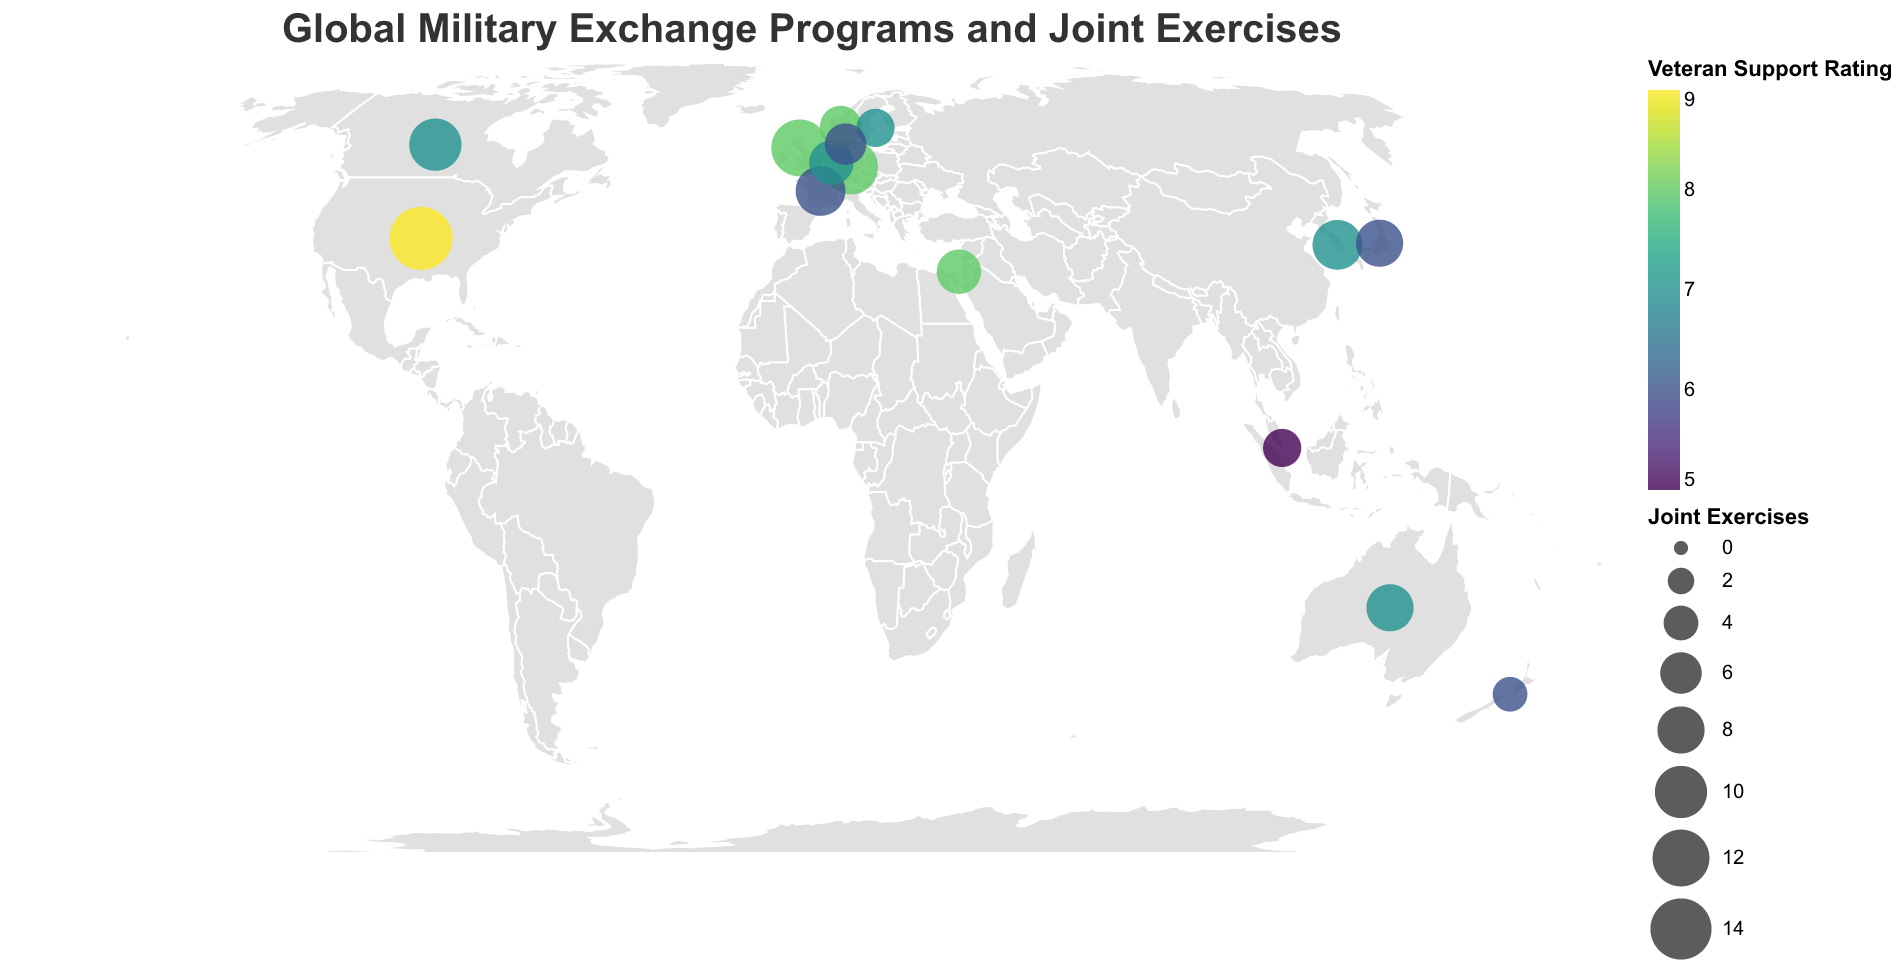What's the title of the figure? The title is usually located at the top of the figure and is clearly stated. Here, it reads "Global Military Exchange Programs and Joint Exercises".
Answer: Global Military Exchange Programs and Joint Exercises How is the size of each circle on the plot determined? The size of each circle is based on the number of Joint Exercises that a country participates in. This can be inferred from the "size" legend referring to Joint Exercises.
Answer: Number of Joint Exercises Which country has the highest Veteran Support Rating and how is it visually represented? By examining the color indicator on the plot, we see that darker colors correspond to a higher Veteran Support Rating. The United States, which is a dark shade close to the value 9 in the legend, has the highest Veteran Support Rating.
Answer: United States How many countries participate in 6 Joint Exercises? By looking at the plot and identifying the circles whose size corresponds to 6 Joint Exercises: Australia, Denmark, Norway, and the Netherlands all have 6 Joint Exercises.
Answer: 4 countries Which country offers the most exchange programs? Examining the tooltip for each country shows that the United States offers the most exchange programs with a value of 10.
Answer: United States Compare the Veteran Support Rating of the United Kingdom and Germany. Which one is higher? Both countries have different shades on the plot. According to the tooltip, the United Kingdom has a Veteran Support Rating of 8, while Germany also has a rating of 8. Thus, they are equal.
Answer: Equal What is the average number of Joint Exercises among countries with a Veteran Support Rating of 7? Countries with a Veteran Support Rating of 7 are Canada, Australia, South Korea, Netherlands, and Sweden. Their Joint Exercise numbers are 10, 8, 9, 7, and 5 respectively. The average is (10 + 8 + 9 + 7 + 5) / 5 = 39 / 5 = 7.8
Answer: 7.8 Which countries have a Veteran Support Rating less than 7? The plot shows different shades indicating the Veteran Support Rating. The tooltip helps identify that France (6), Japan (6), Denmark (6), New Zealand (6), and Singapore (5) have a Veteran Support Rating below 7.
Answer: France, Japan, Denmark, New Zealand, Singapore Identify the country in the Southern Hemisphere with the highest number of Joint Exercises. In the Southern Hemisphere, countries like Australia and New Zealand participate in Joint Exercises. By comparing, Australia has a higher number with 8 Joint Exercises than New Zealand, which has 4.
Answer: Australia 